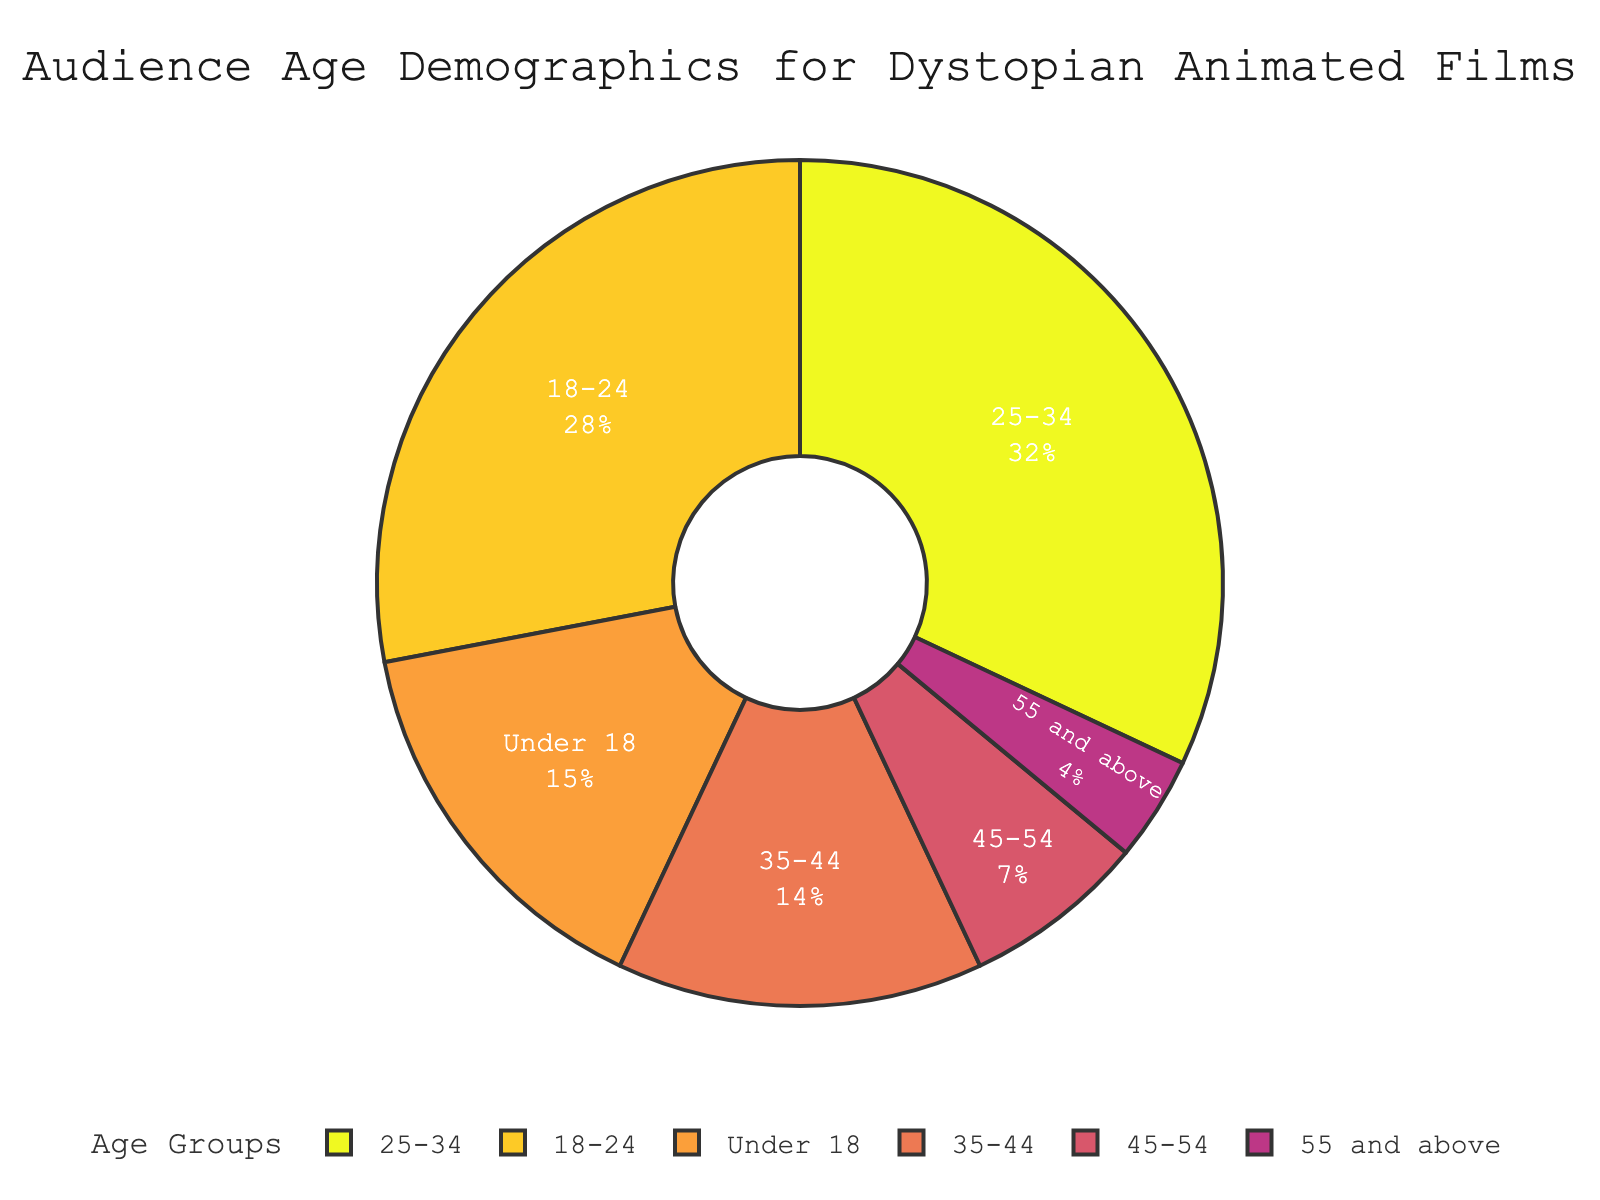What age group has the largest percentage of the audience? The largest segment can be seen visually as the biggest slice of the pie, which is the 25-34 age group.
Answer: 25-34 Which two age groups together make up more than half of the audience? By visually summing the slices, both the 18-24 group (28%) and the 25-34 group (32%) together make up 60%, which is more than half.
Answer: 18-24 and 25-34 Is the percentage of audience members under 18 greater than that of those aged 45 and above groups combined? The Under 18 group is 15%, while 45-54 and 55 and above combined are 7% + 4% = 11%. Therefore, 15% > 11%.
Answer: Yes What is the sum of the percentages of the three smallest age groups? The three smallest groups are 55 and above (4%), 45-54 (7%), and 35-44 (14%). Sum: 4% + 7% + 14% = 25%.
Answer: 25% Which is the least represented age group in the audience? The smallest slice in the pie chart represents the 55 and above group at 4%.
Answer: 55 and above Are there more viewers in the combined group of 35-44 and 45-54 than in the 25-34 age group? The 35-44 group is 14% and the 45-54 group is 7%, together they make 21%. This is less than the 25-34 group, which is 32%.
Answer: No How does the percentage of the 18-24 age group compare to the 35-44 age group? The 18-24 age group is represented by 28%, which is visually greater than the 14% of the 35-44 age group.
Answer: Greater What is the average percentage of the age groups under 18, 18-24, and 25-34? Sum the percentages of these three groups: 15% + 28% + 32% = 75%. Then divide by 3 to get the average: 75% / 3 = 25%.
Answer: 25% If the audience is divided into two groups, those under 35 and those 35 and above, which group constitutes more of the audience? The sums are: under 35 (15% + 28% + 32% = 75%) and 35 and above (14% + 7% + 4% = 25%). The under 35 group is larger.
Answer: Under 35 What percentage of the audience is aged between 18 and 44? Sum the percentages for the 18-24 (28%) and 25-34 (32%) and 35-44 (14%) groups: 28% + 32% + 14% = 74%.
Answer: 74% 